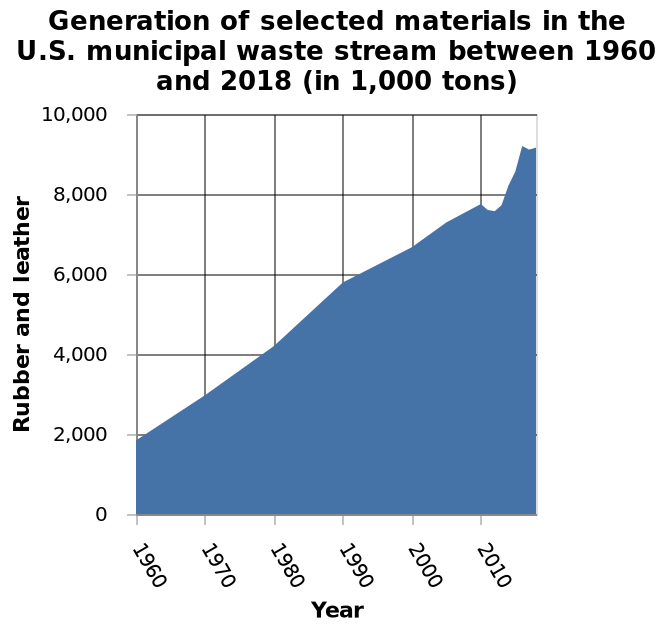<image>
Offer a thorough analysis of the image. Wate in the United States has increased dramatically since the 1950's. What is plotted along the y-axis of the area graph?  Rubber and leather are plotted along the y-axis of the area graph. In which country does the area graph represent the generation of selected materials? The area graph represents the generation of selected materials in the U.S. Which two materials are represented in the chart? The chart represents the data for leather and rubber. Has water in the United States decreased astronomically since the 1950's? No.Wate in the United States has increased dramatically since the 1950's. 